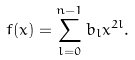Convert formula to latex. <formula><loc_0><loc_0><loc_500><loc_500>f ( x ) = \sum _ { l = 0 } ^ { n - 1 } b _ { l } x ^ { 2 l } .</formula> 